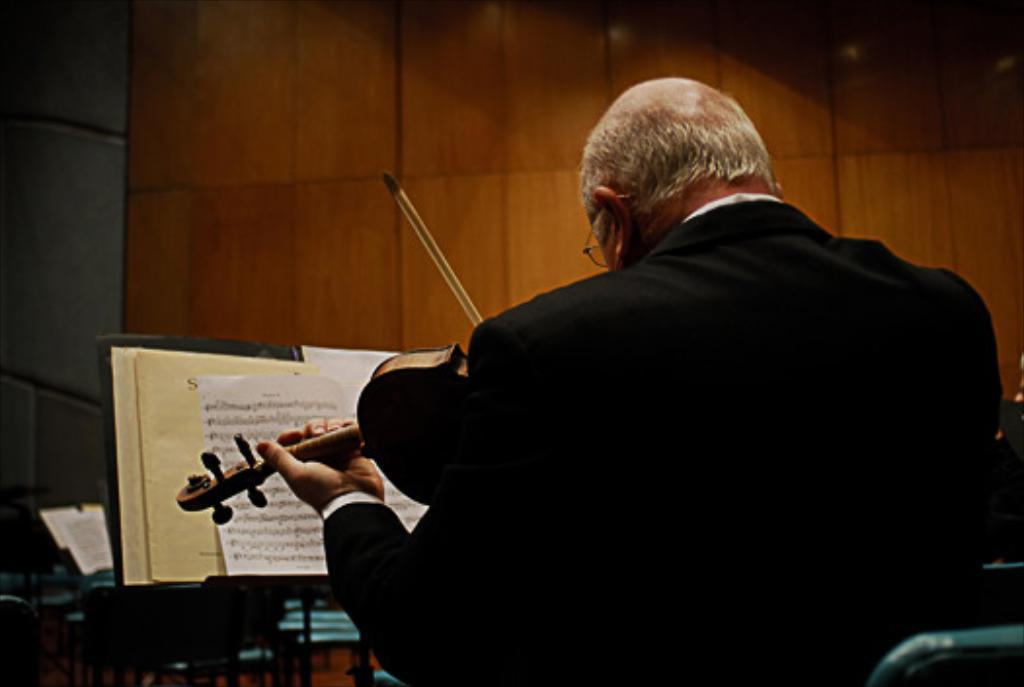What is the man in the image doing? The man is playing a musical instrument. What is in front of the man? There is a book and a stand in front of the man. What can be seen in the background of the image? A: There is a wooden wall in the background of the image. How does the man's playing of the musical instrument contribute to his profit? The image does not provide any information about the man's profit, so it cannot be determined from the image. 